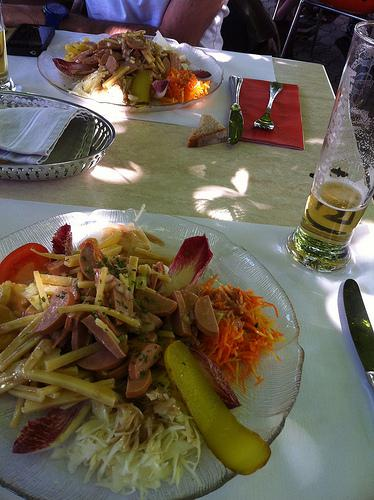Question: where was the photo taken?
Choices:
A. The dance.
B. The bathroom.
C. At dinner.
D. The park.
Answer with the letter. Answer: C Question: what is in the plate?
Choices:
A. Food.
B. Napkin.
C. Fork and knife.
D. Steak.
Answer with the letter. Answer: A Question: what color is the plate?
Choices:
A. Colorless.
B. White.
C. Clear.
D. Pink.
Answer with the letter. Answer: A Question: why is the photo clear?
Choices:
A. It is digital.
B. Good photographer.
C. No smoke.
D. It's during the day.
Answer with the letter. Answer: D Question: who is in the photo?
Choices:
A. A politician.
B. A businessman.
C. Nobody.
D. The wedding party.
Answer with the letter. Answer: C 